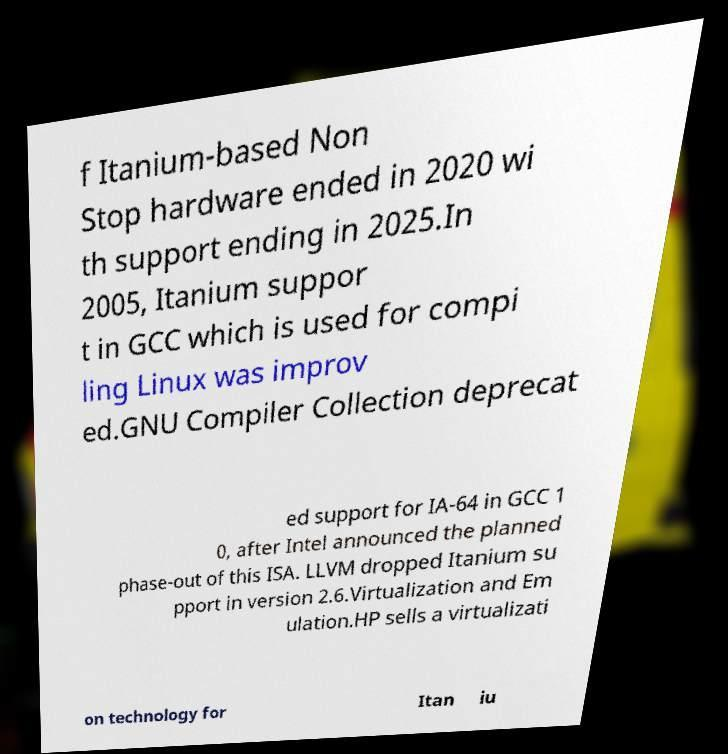Please identify and transcribe the text found in this image. f Itanium-based Non Stop hardware ended in 2020 wi th support ending in 2025.In 2005, Itanium suppor t in GCC which is used for compi ling Linux was improv ed.GNU Compiler Collection deprecat ed support for IA-64 in GCC 1 0, after Intel announced the planned phase-out of this ISA. LLVM dropped Itanium su pport in version 2.6.Virtualization and Em ulation.HP sells a virtualizati on technology for Itan iu 